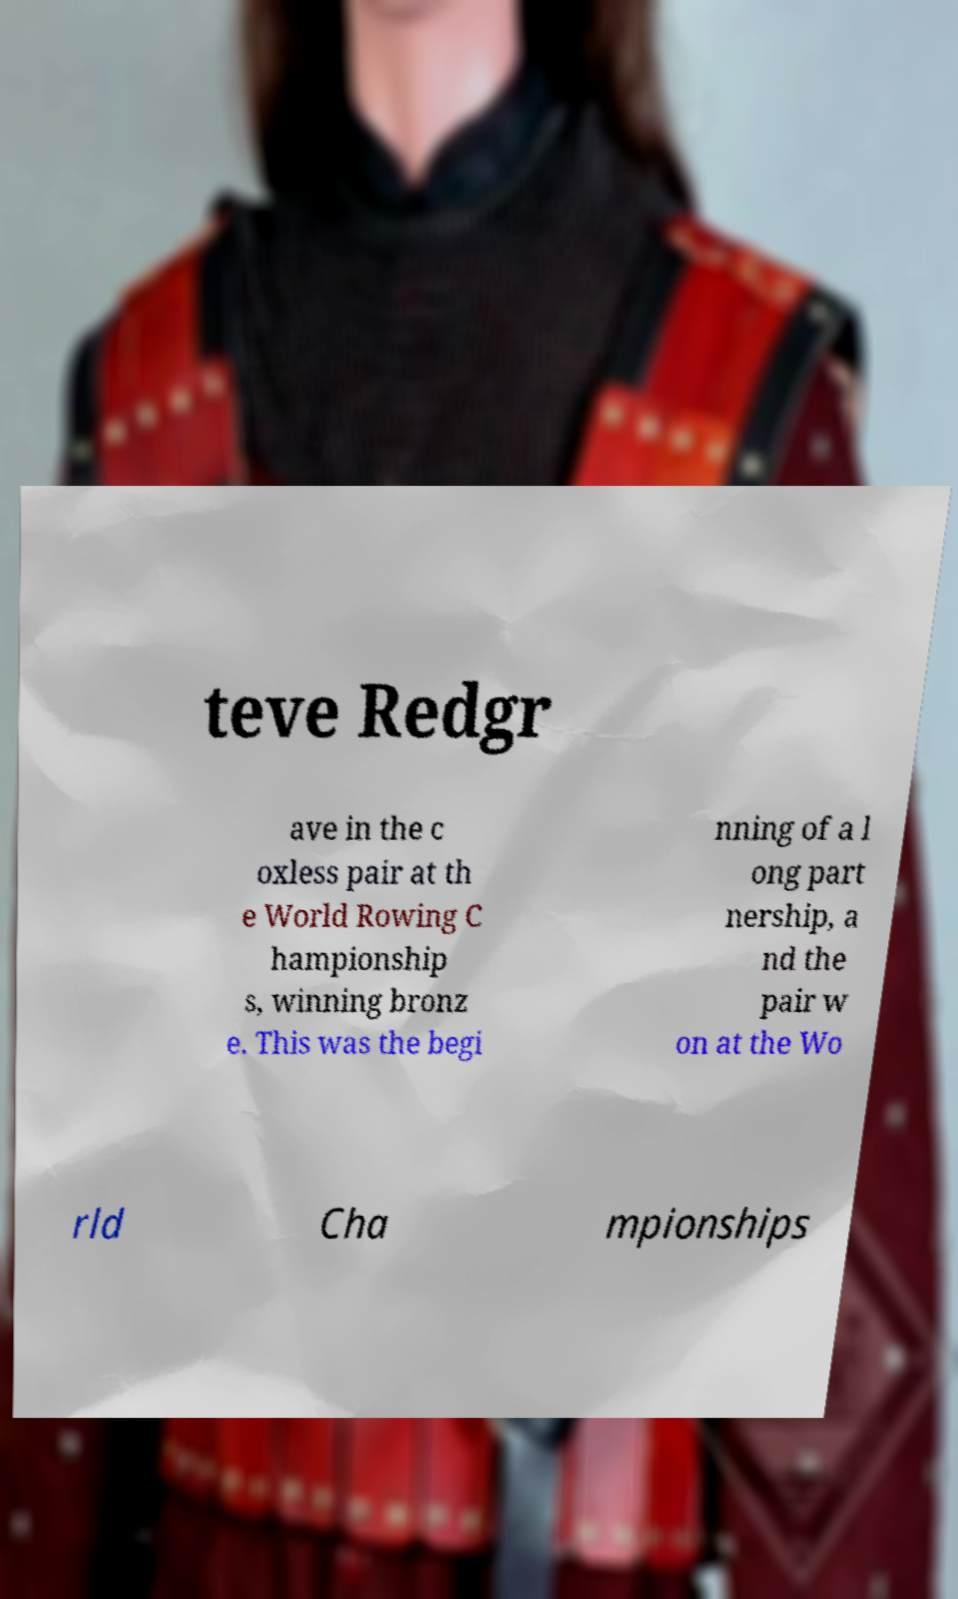There's text embedded in this image that I need extracted. Can you transcribe it verbatim? teve Redgr ave in the c oxless pair at th e World Rowing C hampionship s, winning bronz e. This was the begi nning of a l ong part nership, a nd the pair w on at the Wo rld Cha mpionships 